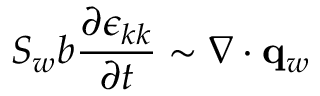<formula> <loc_0><loc_0><loc_500><loc_500>S _ { w } b \frac { \partial \epsilon _ { k k } } { \partial t } \sim \nabla \cdot q _ { w }</formula> 